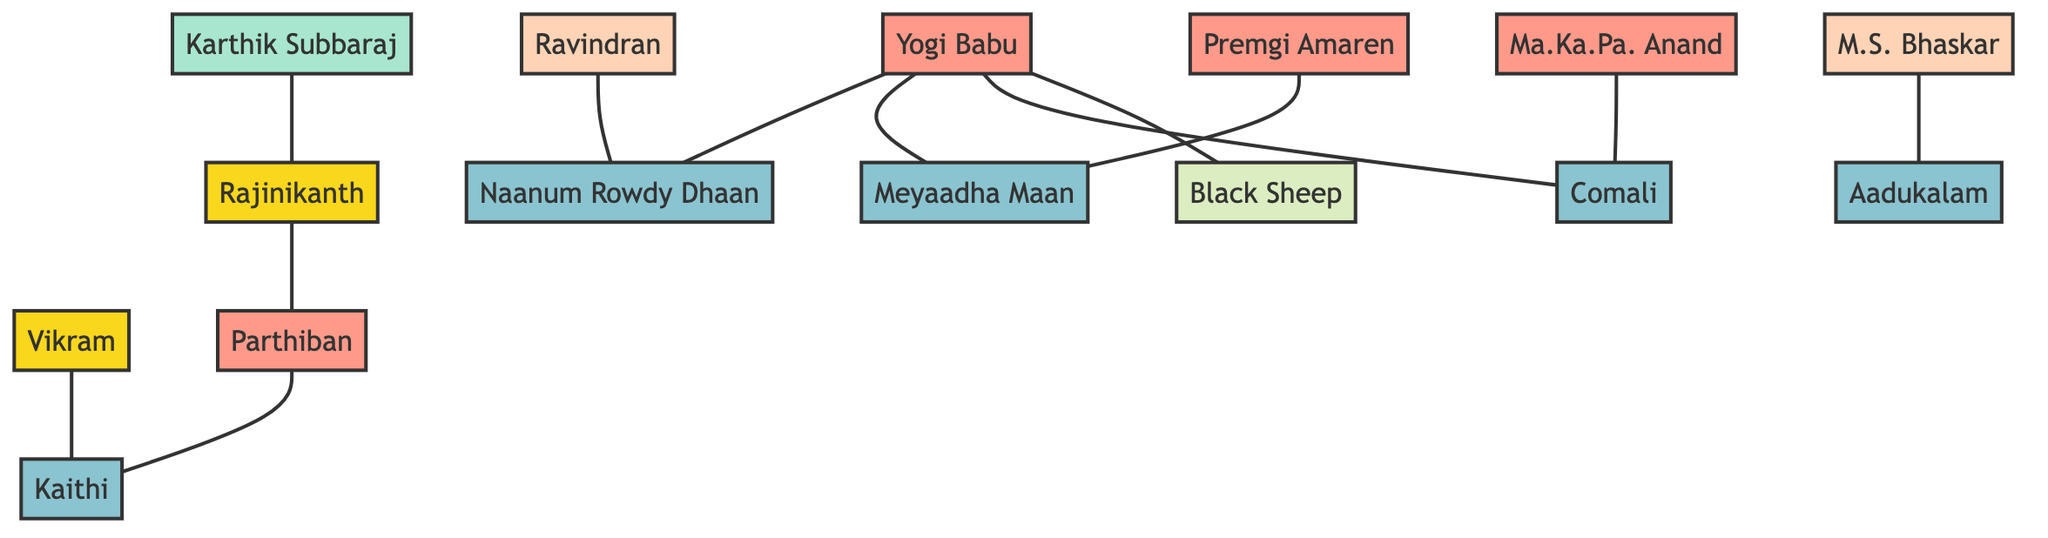What is Yogi Babu's breakout role? Yogi Babu is linked to the movie "Naanum Rowdy Dhaan" with a relationship type of "BreakoutRole." This means this movie marks a significant point in his career.
Answer: Naanum Rowdy Dhaan Which stand-up comedian made their movie debut in "Naanum Rowdy Dhaan"? The diagram shows that Ravindran has a link to "Naanum Rowdy Dhaan" with the relationship type "MovieDebut," indicating this was their first film appearance.
Answer: Ravindran How many movies is Yogi Babu associated with? By inspecting the edges linked to Yogi Babu, we see he is connected to three movies: "Naanum Rowdy Dhaan," "Meyaadha Maan," and "Comali," which means he has associations with three movies in total.
Answer: 3 Which actor and comedian is associated with the movie "Kaithi"? The diagram indicates that both Parthiban has a "BreakoutRole" link with "Kaithi" and Vikram is an "Actor" linked to the same movie, showing their mutual involvement with it.
Answer: Parthiban, Vikram What relationship does Karthik Subbaraj have with Rajinikanth? The diagram shows a direct edge labeled "Directed" connecting Karthik Subbaraj to Rajinikanth, which indicates that Karthik has directed Rajinikanth in a movie.
Answer: Directed How many actor-comedians are linked to "Meyaadha Maan"? By examining the edges, we see that both Yogi Babu and Premgi Amaren are linked to "Meyaadha Maan," establishing that there are two actor-comedians related to this film.
Answer: 2 Which movie marks the debut of Ma.Ka.Pa. Anand? The connection indicates that Ma.Ka.Pa. Anand has a "MovieDebut" relationship with "Comali," which signifies that this was his first appearance in a film.
Answer: Comali What is the connection between Rajinikanth and Parthiban? The diagram indicates that Rajinikanth is connected to Parthiban with a "CoActor" relationship. This implies they have worked together in a film.
Answer: CoActor How many edges are linked to Yogi Babu? Counting the edges associated with Yogi Babu reveals he has five edges linked—the movies "Naanum Rowdy Dhaan," "Meyaadha Maan," and "Comali," and the association with "Black Sheep."
Answer: 5 